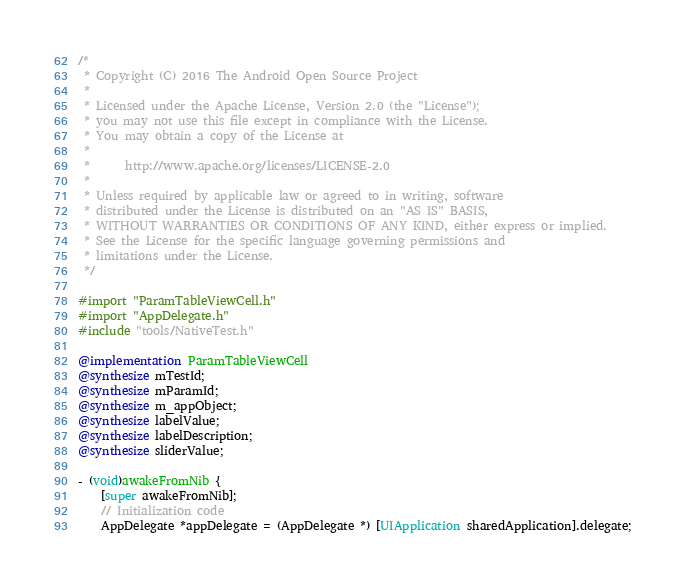<code> <loc_0><loc_0><loc_500><loc_500><_ObjectiveC_>/*
 * Copyright (C) 2016 The Android Open Source Project
 *
 * Licensed under the Apache License, Version 2.0 (the "License");
 * you may not use this file except in compliance with the License.
 * You may obtain a copy of the License at
 *
 *      http://www.apache.org/licenses/LICENSE-2.0
 *
 * Unless required by applicable law or agreed to in writing, software
 * distributed under the License is distributed on an "AS IS" BASIS,
 * WITHOUT WARRANTIES OR CONDITIONS OF ANY KIND, either express or implied.
 * See the License for the specific language governing permissions and
 * limitations under the License.
 */

#import "ParamTableViewCell.h"
#import "AppDelegate.h"
#include "tools/NativeTest.h"

@implementation ParamTableViewCell
@synthesize mTestId;
@synthesize mParamId;
@synthesize m_appObject;
@synthesize labelValue;
@synthesize labelDescription;
@synthesize sliderValue;

- (void)awakeFromNib {
    [super awakeFromNib];
    // Initialization code
    AppDelegate *appDelegate = (AppDelegate *) [UIApplication sharedApplication].delegate;</code> 